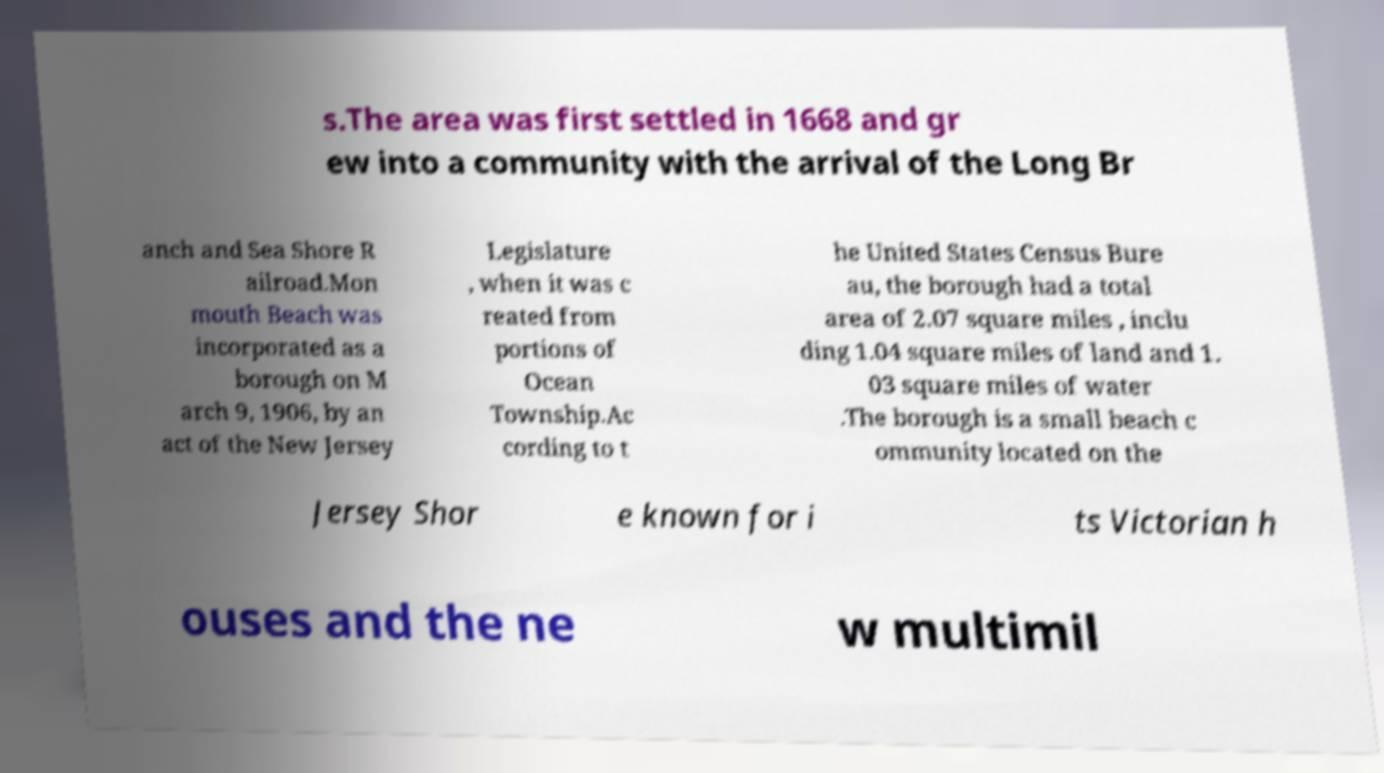There's text embedded in this image that I need extracted. Can you transcribe it verbatim? s.The area was first settled in 1668 and gr ew into a community with the arrival of the Long Br anch and Sea Shore R ailroad.Mon mouth Beach was incorporated as a borough on M arch 9, 1906, by an act of the New Jersey Legislature , when it was c reated from portions of Ocean Township.Ac cording to t he United States Census Bure au, the borough had a total area of 2.07 square miles , inclu ding 1.04 square miles of land and 1. 03 square miles of water .The borough is a small beach c ommunity located on the Jersey Shor e known for i ts Victorian h ouses and the ne w multimil 